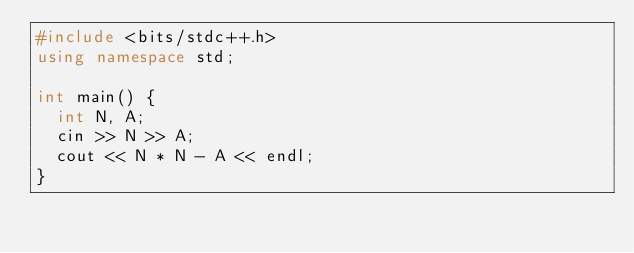Convert code to text. <code><loc_0><loc_0><loc_500><loc_500><_C++_>#include <bits/stdc++.h>
using namespace std;

int main() {
  int N, A;
  cin >> N >> A;
  cout << N * N - A << endl;
}</code> 